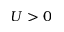Convert formula to latex. <formula><loc_0><loc_0><loc_500><loc_500>U > 0</formula> 